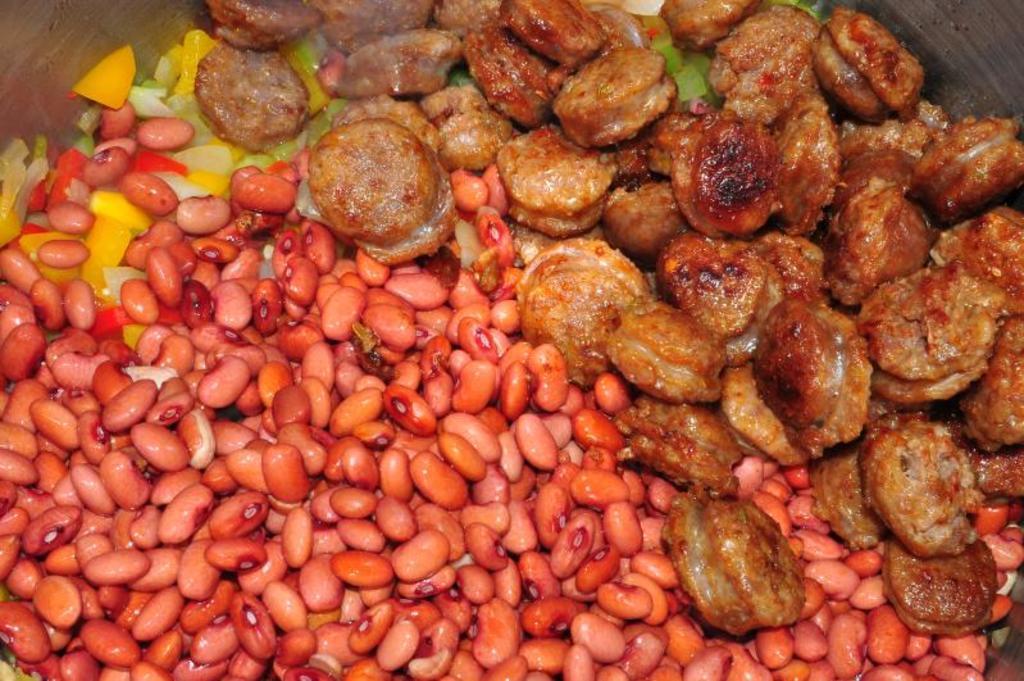Please provide a concise description of this image. In the image there are kidney beans. And also there are some other food items which are in brown and yellow color. 